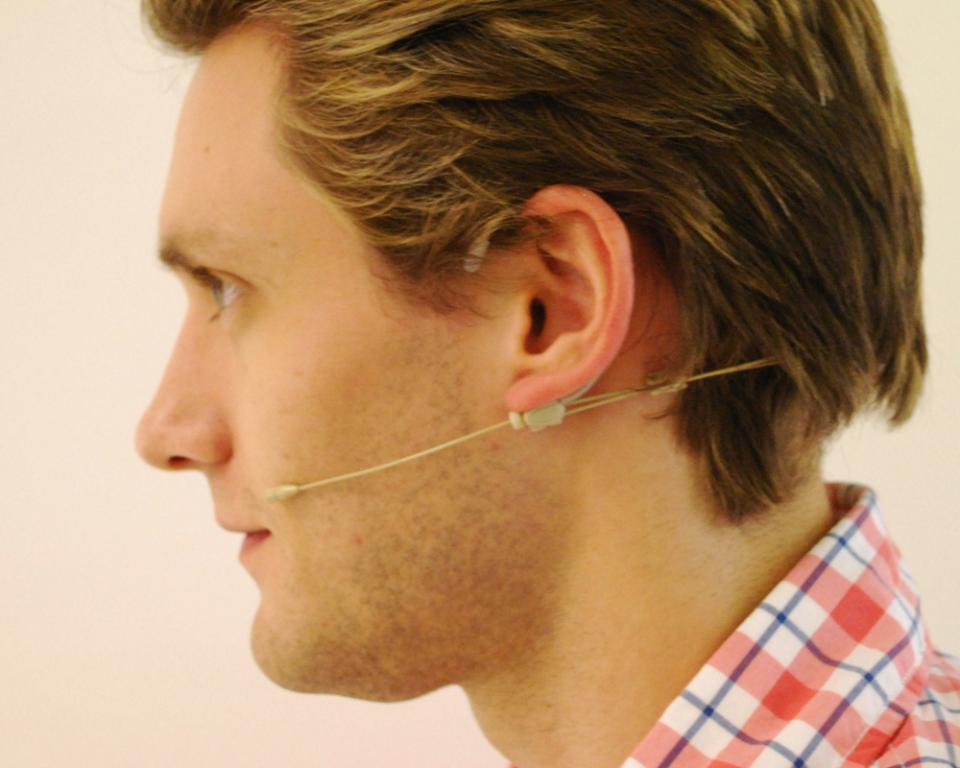Who is present in the image? There is a person in the image. What is the person wearing? The person is wearing a red dress. What can be seen attached to the person's ear? The person has a microphone attached to their ear. What type of seed is the person holding in their hand in the image? There is no seed present in the image; the person has a microphone attached to their ear. 